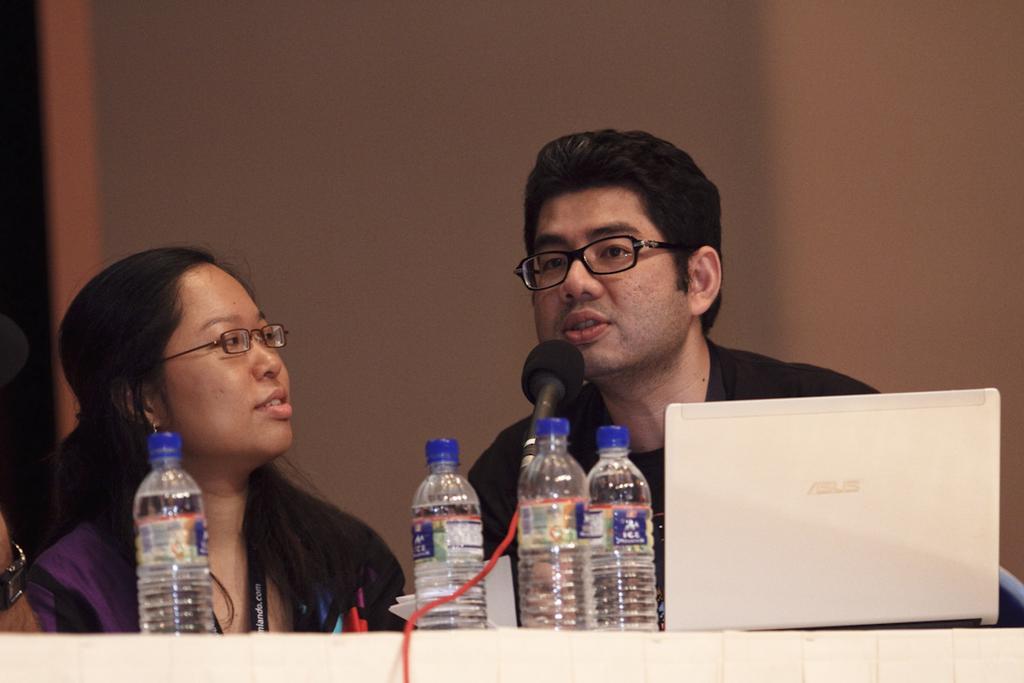How would you summarize this image in a sentence or two? This picture shows a man and woman seated and we see a laptop and few water bottles on the table and we see a man speaking with the help of a microphone 